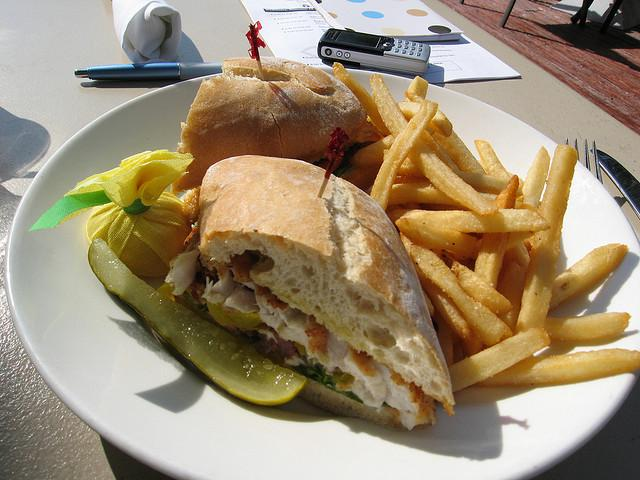Which food element here is likely most sour?

Choices:
A) fries
B) meat
C) bread
D) pickle pickle 